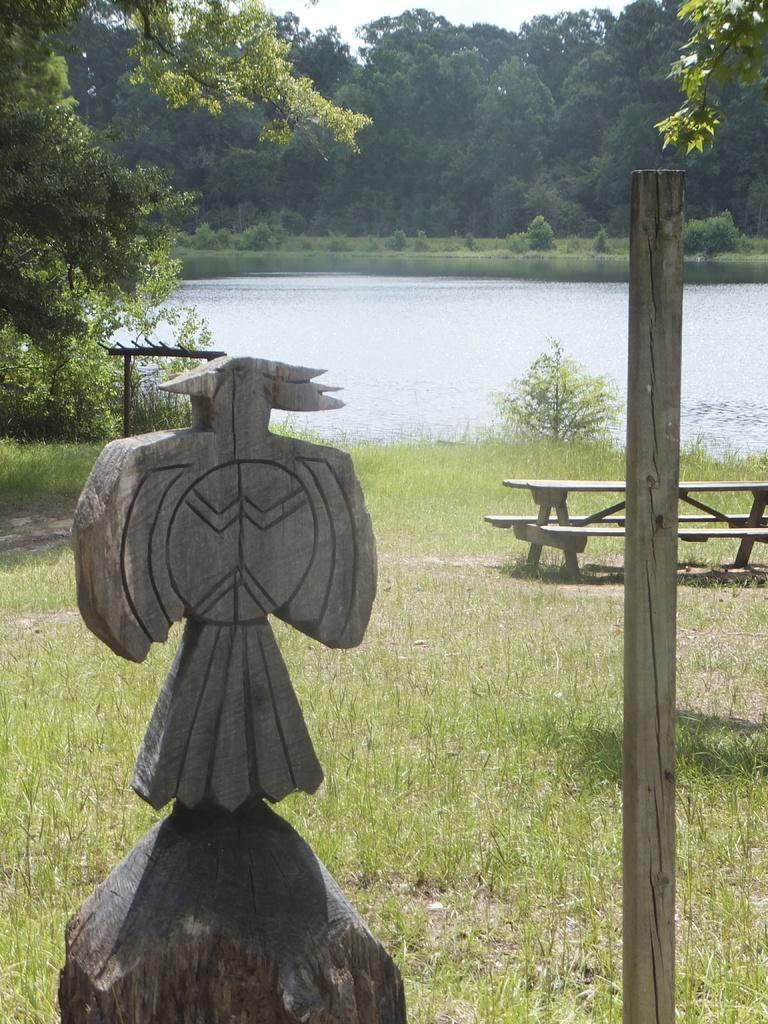Where is the setting of the image? The image is outside of the city. What type of vegetation can be seen in the image? There are trees from right to left in the image. What body of water is present in the image? There is a lake in the image. What type of seating is available in the image? There is a bench in the image. What type of ground is visible at the bottom of the image? There is grass at the bottom of the image. What type of pencil is being used to draw the lake in the image? There is no pencil or drawing activity present in the image; it is a photograph of a real-life scene. 